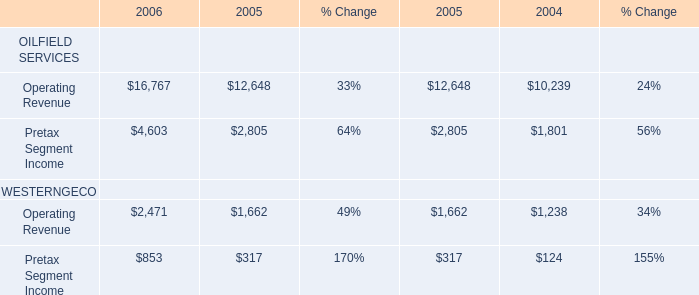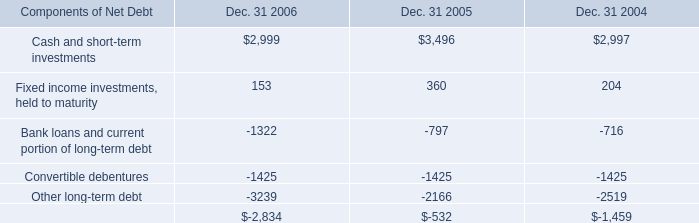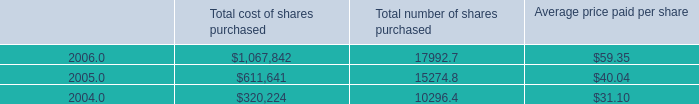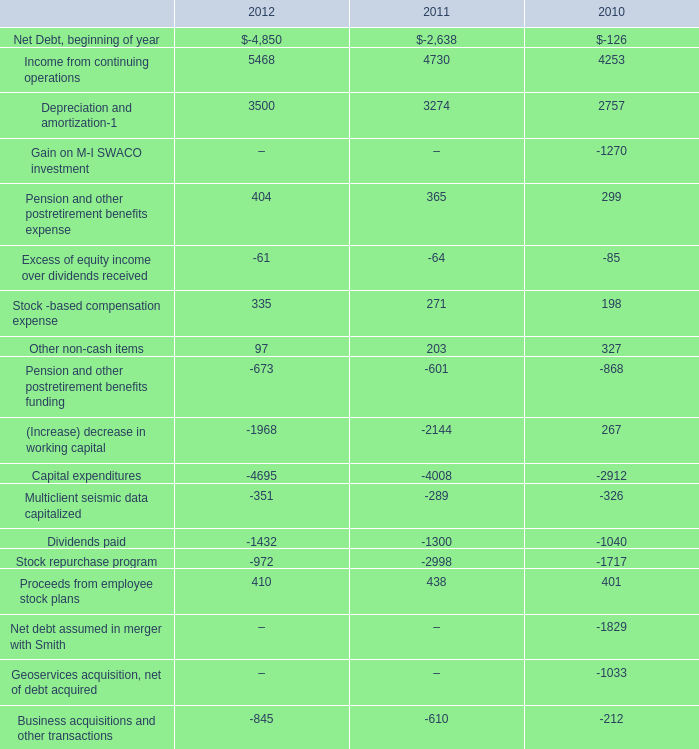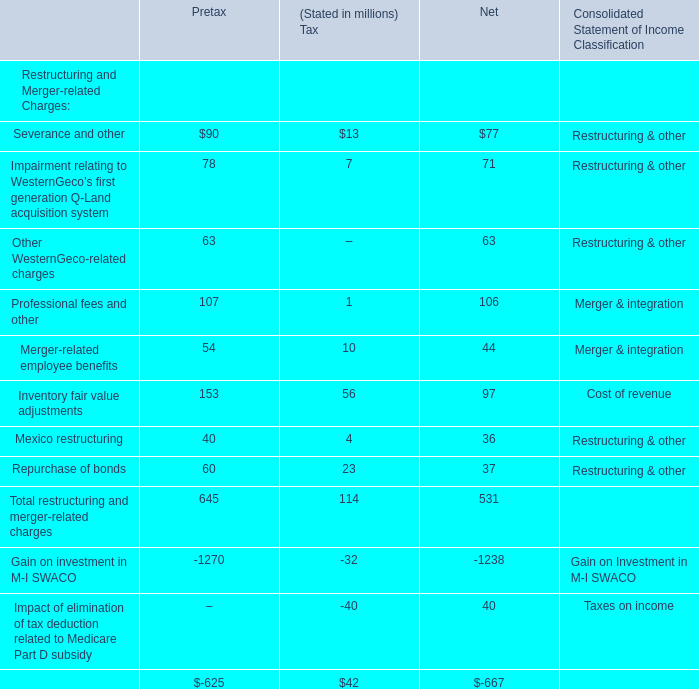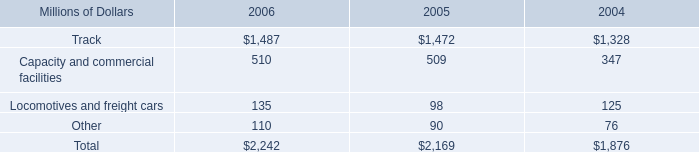what was the percentage change in cash capital investments in track from 2004 to 2005? 
Computations: ((1472 - 1328) / 1328)
Answer: 0.10843. 